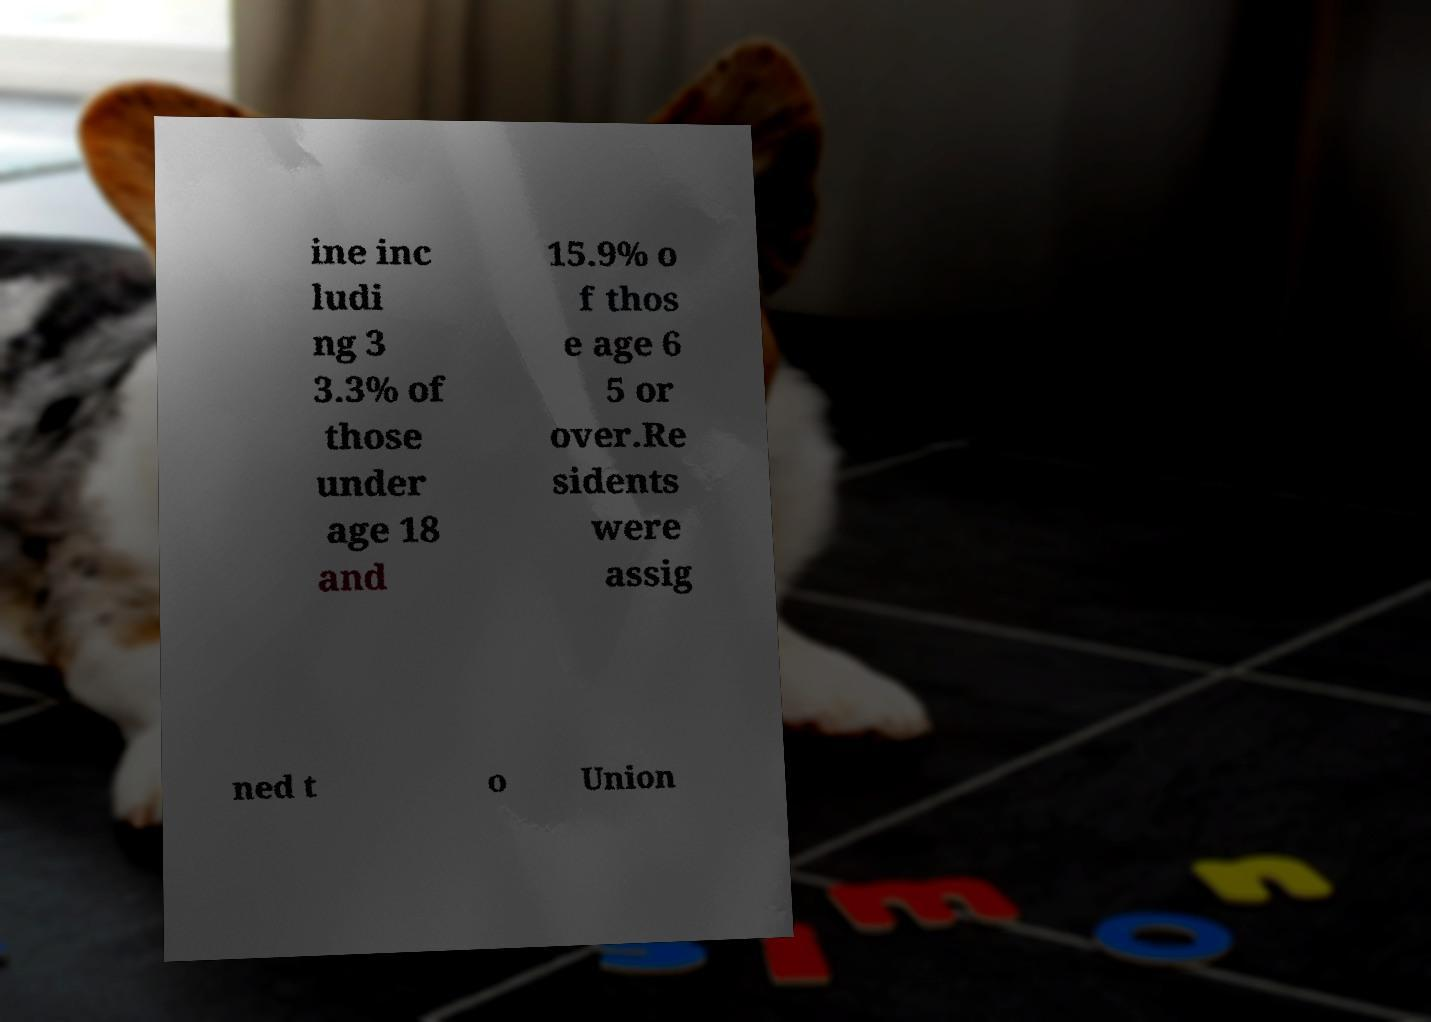Can you read and provide the text displayed in the image?This photo seems to have some interesting text. Can you extract and type it out for me? ine inc ludi ng 3 3.3% of those under age 18 and 15.9% o f thos e age 6 5 or over.Re sidents were assig ned t o Union 